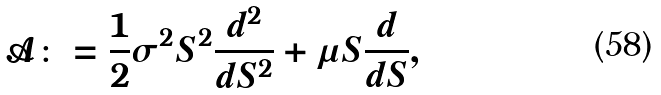<formula> <loc_0><loc_0><loc_500><loc_500>\mathcal { A } \colon = \frac { 1 } { 2 } \sigma ^ { 2 } S ^ { 2 } \frac { d ^ { 2 } } { d S ^ { 2 } } + \mu S \frac { d } { d S } ,</formula> 